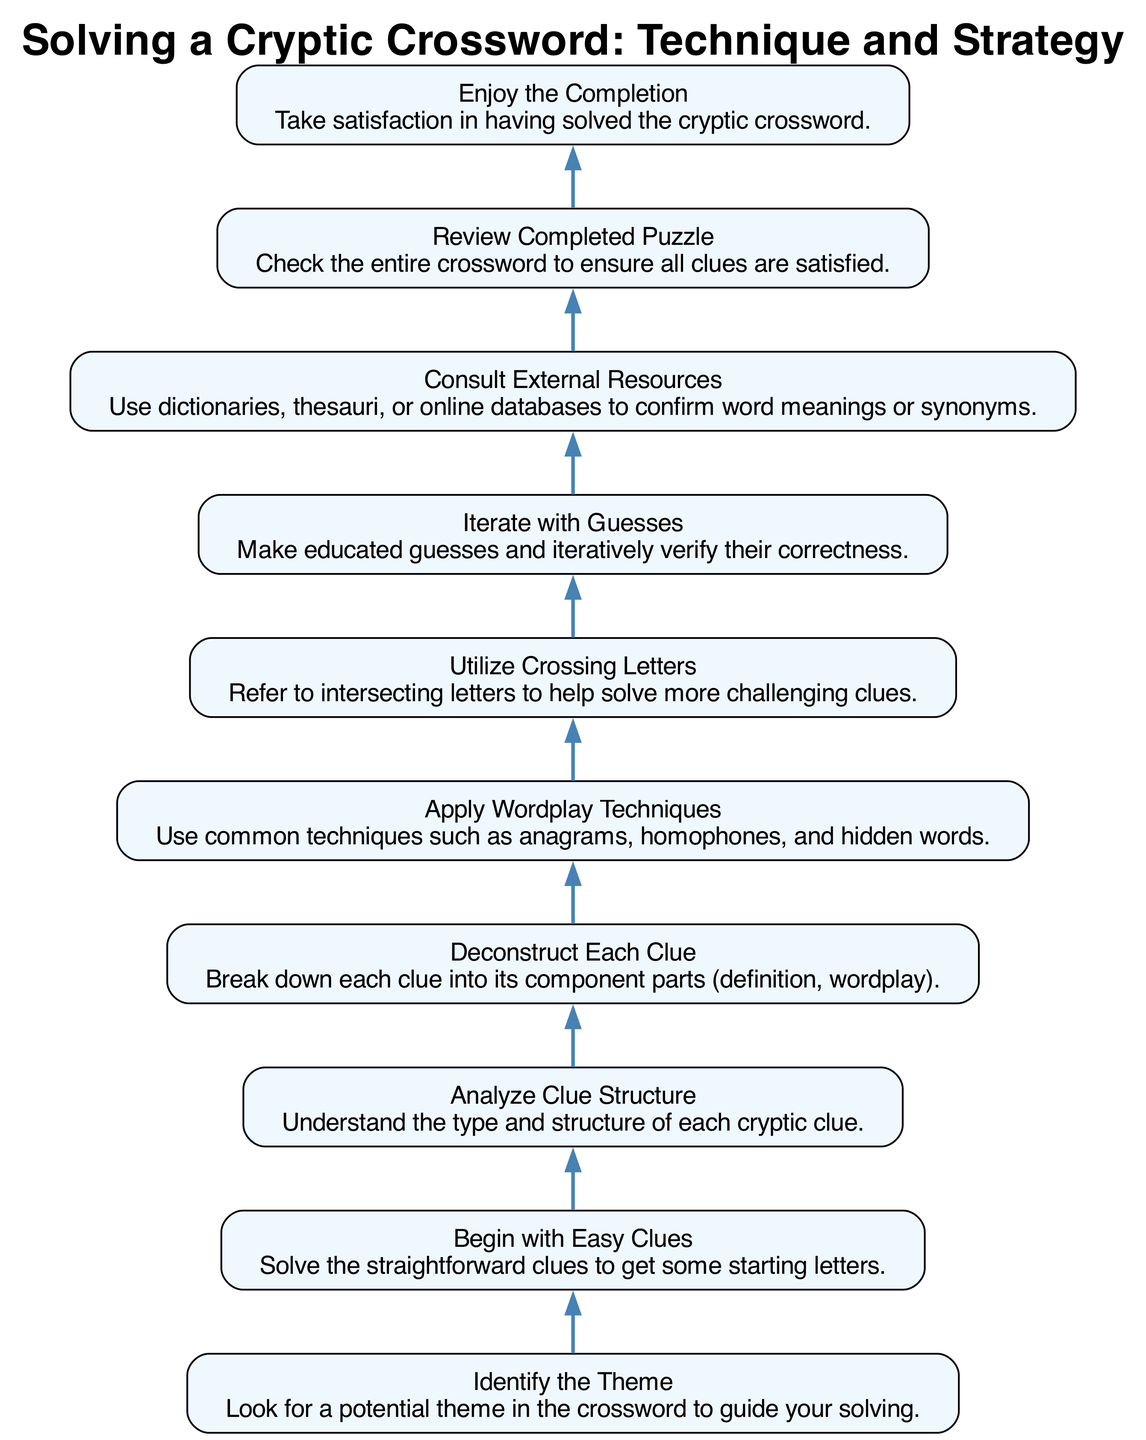What is the first step in solving a cryptic crossword? The diagram shows that the first step is to "Identify the Theme," which is at the bottom of the flow chart.
Answer: Identify the Theme How many steps are there in total to solve a cryptic crossword? By counting all the distinct nodes in the flow chart, we find that there are ten steps listed in the instructions.
Answer: Ten What follows after "Utilize Crossing Letters"? The flow chart indicates that the step that follows "Utilize Crossing Letters" is "Iterate with Guesses."
Answer: Iterate with Guesses Is "Consult External Resources" connected to the initial steps of the diagram? "Consult External Resources" is visually located further up in the flow chart, indicating it is not connected to the initial steps but rather comes after various clue-solving techniques have been applied.
Answer: No What are the two last steps in the sequence of solving a cryptic crossword? The last two steps in the flow chart, as shown towards the top, are "Review Completed Puzzle" followed by "Enjoy the Completion."
Answer: Review Completed Puzzle, Enjoy the Completion How do you apply wordplay techniques after deconstructing clues? According to the flow chart, once clues have been deconstructed, the next logical step is to "Apply Wordplay Techniques," which requires the information from the previous step to effectively solve the clues.
Answer: Apply Wordplay Techniques What type of clues should be solved first according to the flow? The flow chart specifically states to "Begin with Easy Clues," indicating these are the first types of clues to focus on when starting to solve the puzzle.
Answer: Easy Clues What is the relationship between "Analyze Clue Structure" and "Deconstruct Each Clue"? The flow chart shows a direct connection where "Analyze Clue Structure" leads into "Deconstruct Each Clue," indicating that understanding the structure is essential for breaking clues down further.
Answer: Leads to How do you know when to enjoy the completion of the crossword? The flow chart shows that the final step is "Enjoy the Completion," indicating that one can enjoy this after successfully going through all the previous steps, especially after reviewing the completed puzzle.
Answer: After reviewing the completed puzzle 